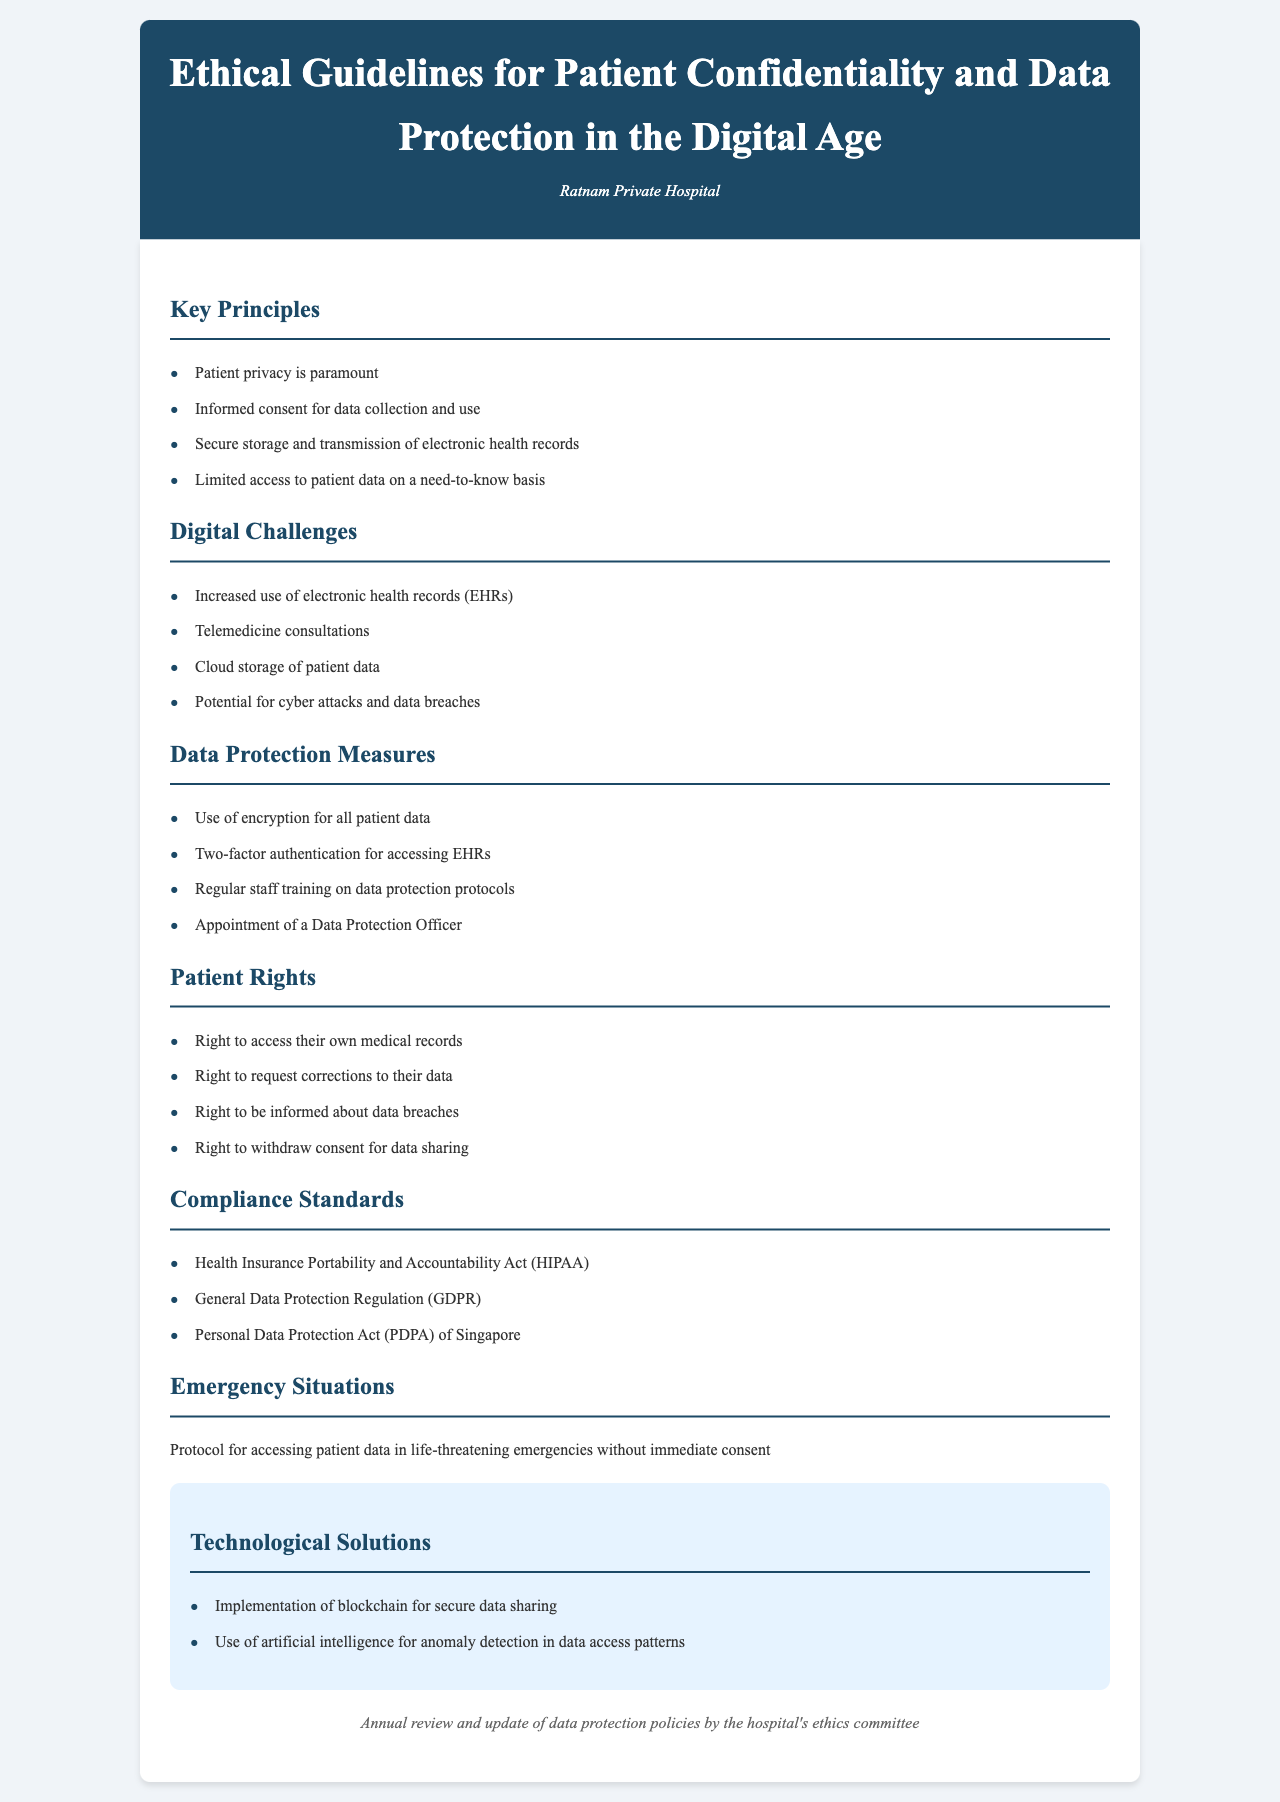What is the title of the document? The title of the document is presented prominently at the top of the page.
Answer: Ethical Guidelines for Patient Confidentiality and Data Protection in the Digital Age What hospital context is mentioned? The hospital context indicates the healthcare institution related to the guidelines.
Answer: Ratnam Private Hospital What are the key principles listed? The key principles outline the core ethical considerations for patient confidentiality.
Answer: Patient privacy is paramount How many digital challenges are identified? The number of digital challenges is mentioned in the relevant section.
Answer: Four What is one data protection measure recommended? The document suggests specific measures to enhance patient data security.
Answer: Use of encryption for all patient data Which regulation relevant to data protection is listed? Regulatory compliance is essential for maintaining ethical standards in data protection.
Answer: Health Insurance Portability and Accountability Act (HIPAA) What rights do patients have regarding their medical records? The rights outlined highlight patients' control over their data.
Answer: Right to access their own medical records What technological solution is suggested for secure data sharing? Technological advancements proposed in the document aim to improve data security.
Answer: Implementation of blockchain for secure data sharing What is the emergency data access protocol? The protocol addresses how to handle patient data in urgent situations without consent.
Answer: Protocol for accessing patient data in life-threatening emergencies without immediate consent 